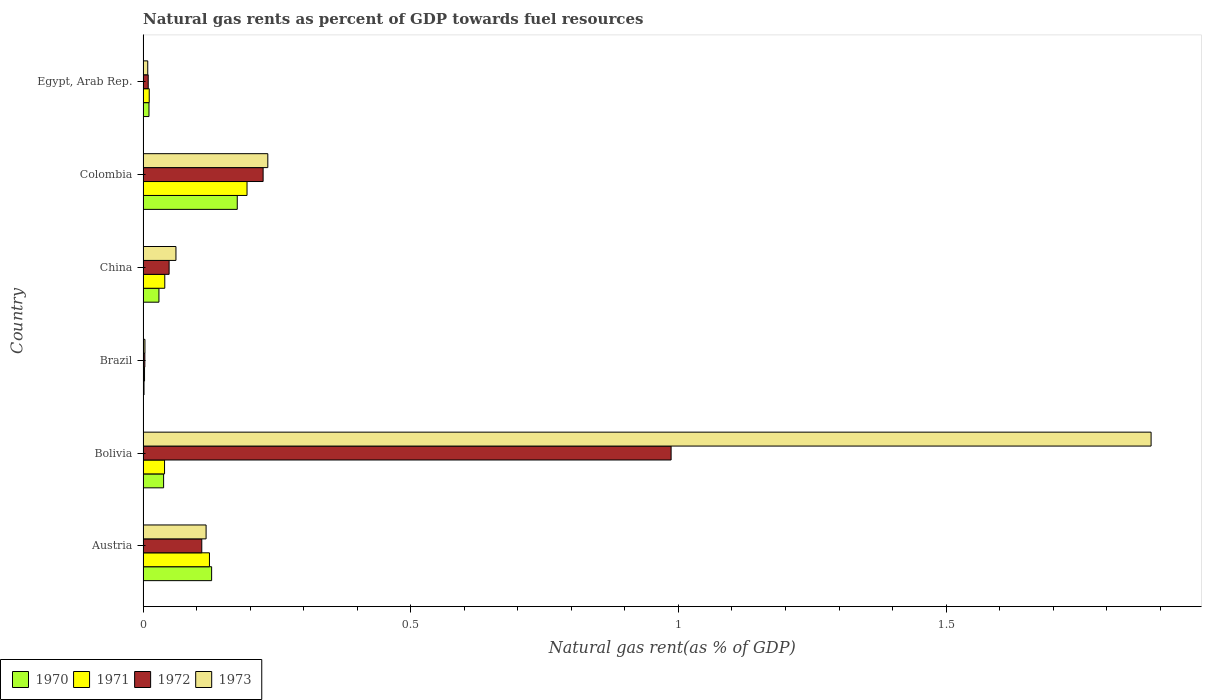How many different coloured bars are there?
Your answer should be compact. 4. How many groups of bars are there?
Offer a very short reply. 6. Are the number of bars per tick equal to the number of legend labels?
Give a very brief answer. Yes. How many bars are there on the 1st tick from the top?
Provide a short and direct response. 4. What is the natural gas rent in 1971 in China?
Make the answer very short. 0.04. Across all countries, what is the maximum natural gas rent in 1973?
Your response must be concise. 1.88. Across all countries, what is the minimum natural gas rent in 1971?
Provide a succinct answer. 0. In which country was the natural gas rent in 1971 maximum?
Your answer should be very brief. Colombia. What is the total natural gas rent in 1970 in the graph?
Offer a very short reply. 0.38. What is the difference between the natural gas rent in 1970 in Bolivia and that in Brazil?
Provide a succinct answer. 0.04. What is the difference between the natural gas rent in 1973 in Egypt, Arab Rep. and the natural gas rent in 1972 in Brazil?
Your answer should be very brief. 0.01. What is the average natural gas rent in 1971 per country?
Make the answer very short. 0.07. What is the difference between the natural gas rent in 1970 and natural gas rent in 1972 in Bolivia?
Provide a short and direct response. -0.95. In how many countries, is the natural gas rent in 1973 greater than 1.3 %?
Keep it short and to the point. 1. What is the ratio of the natural gas rent in 1972 in Brazil to that in China?
Your answer should be very brief. 0.07. What is the difference between the highest and the second highest natural gas rent in 1972?
Offer a very short reply. 0.76. What is the difference between the highest and the lowest natural gas rent in 1971?
Keep it short and to the point. 0.19. In how many countries, is the natural gas rent in 1970 greater than the average natural gas rent in 1970 taken over all countries?
Your response must be concise. 2. Is it the case that in every country, the sum of the natural gas rent in 1973 and natural gas rent in 1970 is greater than the sum of natural gas rent in 1971 and natural gas rent in 1972?
Make the answer very short. No. What does the 4th bar from the top in China represents?
Keep it short and to the point. 1970. What does the 3rd bar from the bottom in Austria represents?
Ensure brevity in your answer.  1972. How many bars are there?
Keep it short and to the point. 24. How many countries are there in the graph?
Provide a succinct answer. 6. Does the graph contain any zero values?
Ensure brevity in your answer.  No. How many legend labels are there?
Provide a succinct answer. 4. How are the legend labels stacked?
Keep it short and to the point. Horizontal. What is the title of the graph?
Offer a very short reply. Natural gas rents as percent of GDP towards fuel resources. What is the label or title of the X-axis?
Provide a short and direct response. Natural gas rent(as % of GDP). What is the Natural gas rent(as % of GDP) of 1970 in Austria?
Your answer should be very brief. 0.13. What is the Natural gas rent(as % of GDP) of 1971 in Austria?
Your answer should be compact. 0.12. What is the Natural gas rent(as % of GDP) of 1972 in Austria?
Your answer should be compact. 0.11. What is the Natural gas rent(as % of GDP) in 1973 in Austria?
Offer a very short reply. 0.12. What is the Natural gas rent(as % of GDP) in 1970 in Bolivia?
Your answer should be compact. 0.04. What is the Natural gas rent(as % of GDP) in 1971 in Bolivia?
Your answer should be compact. 0.04. What is the Natural gas rent(as % of GDP) in 1972 in Bolivia?
Your answer should be very brief. 0.99. What is the Natural gas rent(as % of GDP) in 1973 in Bolivia?
Make the answer very short. 1.88. What is the Natural gas rent(as % of GDP) of 1970 in Brazil?
Keep it short and to the point. 0. What is the Natural gas rent(as % of GDP) in 1971 in Brazil?
Your response must be concise. 0. What is the Natural gas rent(as % of GDP) of 1972 in Brazil?
Give a very brief answer. 0. What is the Natural gas rent(as % of GDP) in 1973 in Brazil?
Offer a terse response. 0. What is the Natural gas rent(as % of GDP) in 1970 in China?
Offer a terse response. 0.03. What is the Natural gas rent(as % of GDP) in 1971 in China?
Offer a very short reply. 0.04. What is the Natural gas rent(as % of GDP) in 1972 in China?
Offer a terse response. 0.05. What is the Natural gas rent(as % of GDP) of 1973 in China?
Your answer should be compact. 0.06. What is the Natural gas rent(as % of GDP) in 1970 in Colombia?
Make the answer very short. 0.18. What is the Natural gas rent(as % of GDP) of 1971 in Colombia?
Offer a terse response. 0.19. What is the Natural gas rent(as % of GDP) in 1972 in Colombia?
Offer a very short reply. 0.22. What is the Natural gas rent(as % of GDP) in 1973 in Colombia?
Provide a succinct answer. 0.23. What is the Natural gas rent(as % of GDP) in 1970 in Egypt, Arab Rep.?
Ensure brevity in your answer.  0.01. What is the Natural gas rent(as % of GDP) of 1971 in Egypt, Arab Rep.?
Keep it short and to the point. 0.01. What is the Natural gas rent(as % of GDP) in 1972 in Egypt, Arab Rep.?
Make the answer very short. 0.01. What is the Natural gas rent(as % of GDP) in 1973 in Egypt, Arab Rep.?
Make the answer very short. 0.01. Across all countries, what is the maximum Natural gas rent(as % of GDP) in 1970?
Your answer should be very brief. 0.18. Across all countries, what is the maximum Natural gas rent(as % of GDP) of 1971?
Your response must be concise. 0.19. Across all countries, what is the maximum Natural gas rent(as % of GDP) in 1972?
Offer a very short reply. 0.99. Across all countries, what is the maximum Natural gas rent(as % of GDP) in 1973?
Give a very brief answer. 1.88. Across all countries, what is the minimum Natural gas rent(as % of GDP) in 1970?
Provide a succinct answer. 0. Across all countries, what is the minimum Natural gas rent(as % of GDP) in 1971?
Provide a succinct answer. 0. Across all countries, what is the minimum Natural gas rent(as % of GDP) in 1972?
Give a very brief answer. 0. Across all countries, what is the minimum Natural gas rent(as % of GDP) in 1973?
Make the answer very short. 0. What is the total Natural gas rent(as % of GDP) of 1970 in the graph?
Provide a short and direct response. 0.38. What is the total Natural gas rent(as % of GDP) in 1971 in the graph?
Your response must be concise. 0.41. What is the total Natural gas rent(as % of GDP) of 1972 in the graph?
Ensure brevity in your answer.  1.38. What is the total Natural gas rent(as % of GDP) of 1973 in the graph?
Offer a terse response. 2.31. What is the difference between the Natural gas rent(as % of GDP) of 1970 in Austria and that in Bolivia?
Provide a succinct answer. 0.09. What is the difference between the Natural gas rent(as % of GDP) of 1971 in Austria and that in Bolivia?
Offer a very short reply. 0.08. What is the difference between the Natural gas rent(as % of GDP) of 1972 in Austria and that in Bolivia?
Your answer should be very brief. -0.88. What is the difference between the Natural gas rent(as % of GDP) of 1973 in Austria and that in Bolivia?
Keep it short and to the point. -1.77. What is the difference between the Natural gas rent(as % of GDP) in 1970 in Austria and that in Brazil?
Offer a very short reply. 0.13. What is the difference between the Natural gas rent(as % of GDP) of 1971 in Austria and that in Brazil?
Provide a short and direct response. 0.12. What is the difference between the Natural gas rent(as % of GDP) of 1972 in Austria and that in Brazil?
Make the answer very short. 0.11. What is the difference between the Natural gas rent(as % of GDP) in 1973 in Austria and that in Brazil?
Give a very brief answer. 0.11. What is the difference between the Natural gas rent(as % of GDP) of 1970 in Austria and that in China?
Make the answer very short. 0.1. What is the difference between the Natural gas rent(as % of GDP) in 1971 in Austria and that in China?
Provide a succinct answer. 0.08. What is the difference between the Natural gas rent(as % of GDP) in 1972 in Austria and that in China?
Keep it short and to the point. 0.06. What is the difference between the Natural gas rent(as % of GDP) of 1973 in Austria and that in China?
Make the answer very short. 0.06. What is the difference between the Natural gas rent(as % of GDP) of 1970 in Austria and that in Colombia?
Your answer should be compact. -0.05. What is the difference between the Natural gas rent(as % of GDP) of 1971 in Austria and that in Colombia?
Provide a succinct answer. -0.07. What is the difference between the Natural gas rent(as % of GDP) of 1972 in Austria and that in Colombia?
Your answer should be very brief. -0.11. What is the difference between the Natural gas rent(as % of GDP) of 1973 in Austria and that in Colombia?
Keep it short and to the point. -0.12. What is the difference between the Natural gas rent(as % of GDP) in 1970 in Austria and that in Egypt, Arab Rep.?
Give a very brief answer. 0.12. What is the difference between the Natural gas rent(as % of GDP) of 1971 in Austria and that in Egypt, Arab Rep.?
Your response must be concise. 0.11. What is the difference between the Natural gas rent(as % of GDP) of 1972 in Austria and that in Egypt, Arab Rep.?
Give a very brief answer. 0.1. What is the difference between the Natural gas rent(as % of GDP) in 1973 in Austria and that in Egypt, Arab Rep.?
Offer a very short reply. 0.11. What is the difference between the Natural gas rent(as % of GDP) in 1970 in Bolivia and that in Brazil?
Your answer should be very brief. 0.04. What is the difference between the Natural gas rent(as % of GDP) of 1971 in Bolivia and that in Brazil?
Ensure brevity in your answer.  0.04. What is the difference between the Natural gas rent(as % of GDP) of 1973 in Bolivia and that in Brazil?
Ensure brevity in your answer.  1.88. What is the difference between the Natural gas rent(as % of GDP) in 1970 in Bolivia and that in China?
Give a very brief answer. 0.01. What is the difference between the Natural gas rent(as % of GDP) of 1971 in Bolivia and that in China?
Provide a succinct answer. -0. What is the difference between the Natural gas rent(as % of GDP) in 1972 in Bolivia and that in China?
Your answer should be very brief. 0.94. What is the difference between the Natural gas rent(as % of GDP) in 1973 in Bolivia and that in China?
Your answer should be very brief. 1.82. What is the difference between the Natural gas rent(as % of GDP) of 1970 in Bolivia and that in Colombia?
Your response must be concise. -0.14. What is the difference between the Natural gas rent(as % of GDP) in 1971 in Bolivia and that in Colombia?
Offer a very short reply. -0.15. What is the difference between the Natural gas rent(as % of GDP) in 1972 in Bolivia and that in Colombia?
Give a very brief answer. 0.76. What is the difference between the Natural gas rent(as % of GDP) in 1973 in Bolivia and that in Colombia?
Give a very brief answer. 1.65. What is the difference between the Natural gas rent(as % of GDP) in 1970 in Bolivia and that in Egypt, Arab Rep.?
Offer a very short reply. 0.03. What is the difference between the Natural gas rent(as % of GDP) of 1971 in Bolivia and that in Egypt, Arab Rep.?
Offer a very short reply. 0.03. What is the difference between the Natural gas rent(as % of GDP) in 1972 in Bolivia and that in Egypt, Arab Rep.?
Ensure brevity in your answer.  0.98. What is the difference between the Natural gas rent(as % of GDP) of 1973 in Bolivia and that in Egypt, Arab Rep.?
Your answer should be very brief. 1.87. What is the difference between the Natural gas rent(as % of GDP) in 1970 in Brazil and that in China?
Give a very brief answer. -0.03. What is the difference between the Natural gas rent(as % of GDP) of 1971 in Brazil and that in China?
Provide a succinct answer. -0.04. What is the difference between the Natural gas rent(as % of GDP) in 1972 in Brazil and that in China?
Keep it short and to the point. -0.05. What is the difference between the Natural gas rent(as % of GDP) of 1973 in Brazil and that in China?
Provide a short and direct response. -0.06. What is the difference between the Natural gas rent(as % of GDP) of 1970 in Brazil and that in Colombia?
Your answer should be very brief. -0.17. What is the difference between the Natural gas rent(as % of GDP) of 1971 in Brazil and that in Colombia?
Provide a short and direct response. -0.19. What is the difference between the Natural gas rent(as % of GDP) in 1972 in Brazil and that in Colombia?
Provide a succinct answer. -0.22. What is the difference between the Natural gas rent(as % of GDP) of 1973 in Brazil and that in Colombia?
Your response must be concise. -0.23. What is the difference between the Natural gas rent(as % of GDP) of 1970 in Brazil and that in Egypt, Arab Rep.?
Your answer should be compact. -0.01. What is the difference between the Natural gas rent(as % of GDP) in 1971 in Brazil and that in Egypt, Arab Rep.?
Your response must be concise. -0.01. What is the difference between the Natural gas rent(as % of GDP) of 1972 in Brazil and that in Egypt, Arab Rep.?
Ensure brevity in your answer.  -0.01. What is the difference between the Natural gas rent(as % of GDP) of 1973 in Brazil and that in Egypt, Arab Rep.?
Provide a short and direct response. -0.01. What is the difference between the Natural gas rent(as % of GDP) in 1970 in China and that in Colombia?
Your answer should be very brief. -0.15. What is the difference between the Natural gas rent(as % of GDP) of 1971 in China and that in Colombia?
Offer a very short reply. -0.15. What is the difference between the Natural gas rent(as % of GDP) in 1972 in China and that in Colombia?
Ensure brevity in your answer.  -0.18. What is the difference between the Natural gas rent(as % of GDP) in 1973 in China and that in Colombia?
Ensure brevity in your answer.  -0.17. What is the difference between the Natural gas rent(as % of GDP) in 1970 in China and that in Egypt, Arab Rep.?
Your answer should be compact. 0.02. What is the difference between the Natural gas rent(as % of GDP) in 1971 in China and that in Egypt, Arab Rep.?
Ensure brevity in your answer.  0.03. What is the difference between the Natural gas rent(as % of GDP) in 1972 in China and that in Egypt, Arab Rep.?
Keep it short and to the point. 0.04. What is the difference between the Natural gas rent(as % of GDP) in 1973 in China and that in Egypt, Arab Rep.?
Offer a terse response. 0.05. What is the difference between the Natural gas rent(as % of GDP) in 1970 in Colombia and that in Egypt, Arab Rep.?
Your answer should be compact. 0.16. What is the difference between the Natural gas rent(as % of GDP) in 1971 in Colombia and that in Egypt, Arab Rep.?
Offer a very short reply. 0.18. What is the difference between the Natural gas rent(as % of GDP) in 1972 in Colombia and that in Egypt, Arab Rep.?
Your response must be concise. 0.21. What is the difference between the Natural gas rent(as % of GDP) of 1973 in Colombia and that in Egypt, Arab Rep.?
Your answer should be compact. 0.22. What is the difference between the Natural gas rent(as % of GDP) of 1970 in Austria and the Natural gas rent(as % of GDP) of 1971 in Bolivia?
Offer a very short reply. 0.09. What is the difference between the Natural gas rent(as % of GDP) of 1970 in Austria and the Natural gas rent(as % of GDP) of 1972 in Bolivia?
Make the answer very short. -0.86. What is the difference between the Natural gas rent(as % of GDP) of 1970 in Austria and the Natural gas rent(as % of GDP) of 1973 in Bolivia?
Your response must be concise. -1.75. What is the difference between the Natural gas rent(as % of GDP) of 1971 in Austria and the Natural gas rent(as % of GDP) of 1972 in Bolivia?
Your answer should be compact. -0.86. What is the difference between the Natural gas rent(as % of GDP) of 1971 in Austria and the Natural gas rent(as % of GDP) of 1973 in Bolivia?
Offer a very short reply. -1.76. What is the difference between the Natural gas rent(as % of GDP) of 1972 in Austria and the Natural gas rent(as % of GDP) of 1973 in Bolivia?
Make the answer very short. -1.77. What is the difference between the Natural gas rent(as % of GDP) of 1970 in Austria and the Natural gas rent(as % of GDP) of 1971 in Brazil?
Your answer should be very brief. 0.13. What is the difference between the Natural gas rent(as % of GDP) of 1970 in Austria and the Natural gas rent(as % of GDP) of 1972 in Brazil?
Provide a short and direct response. 0.12. What is the difference between the Natural gas rent(as % of GDP) of 1970 in Austria and the Natural gas rent(as % of GDP) of 1973 in Brazil?
Offer a very short reply. 0.12. What is the difference between the Natural gas rent(as % of GDP) in 1971 in Austria and the Natural gas rent(as % of GDP) in 1972 in Brazil?
Your response must be concise. 0.12. What is the difference between the Natural gas rent(as % of GDP) of 1971 in Austria and the Natural gas rent(as % of GDP) of 1973 in Brazil?
Your answer should be very brief. 0.12. What is the difference between the Natural gas rent(as % of GDP) of 1972 in Austria and the Natural gas rent(as % of GDP) of 1973 in Brazil?
Give a very brief answer. 0.11. What is the difference between the Natural gas rent(as % of GDP) in 1970 in Austria and the Natural gas rent(as % of GDP) in 1971 in China?
Your answer should be very brief. 0.09. What is the difference between the Natural gas rent(as % of GDP) in 1970 in Austria and the Natural gas rent(as % of GDP) in 1972 in China?
Offer a very short reply. 0.08. What is the difference between the Natural gas rent(as % of GDP) in 1970 in Austria and the Natural gas rent(as % of GDP) in 1973 in China?
Offer a terse response. 0.07. What is the difference between the Natural gas rent(as % of GDP) in 1971 in Austria and the Natural gas rent(as % of GDP) in 1972 in China?
Your answer should be very brief. 0.08. What is the difference between the Natural gas rent(as % of GDP) of 1971 in Austria and the Natural gas rent(as % of GDP) of 1973 in China?
Offer a very short reply. 0.06. What is the difference between the Natural gas rent(as % of GDP) in 1972 in Austria and the Natural gas rent(as % of GDP) in 1973 in China?
Offer a very short reply. 0.05. What is the difference between the Natural gas rent(as % of GDP) of 1970 in Austria and the Natural gas rent(as % of GDP) of 1971 in Colombia?
Give a very brief answer. -0.07. What is the difference between the Natural gas rent(as % of GDP) of 1970 in Austria and the Natural gas rent(as % of GDP) of 1972 in Colombia?
Your answer should be compact. -0.1. What is the difference between the Natural gas rent(as % of GDP) of 1970 in Austria and the Natural gas rent(as % of GDP) of 1973 in Colombia?
Keep it short and to the point. -0.1. What is the difference between the Natural gas rent(as % of GDP) of 1971 in Austria and the Natural gas rent(as % of GDP) of 1972 in Colombia?
Provide a short and direct response. -0.1. What is the difference between the Natural gas rent(as % of GDP) of 1971 in Austria and the Natural gas rent(as % of GDP) of 1973 in Colombia?
Ensure brevity in your answer.  -0.11. What is the difference between the Natural gas rent(as % of GDP) in 1972 in Austria and the Natural gas rent(as % of GDP) in 1973 in Colombia?
Give a very brief answer. -0.12. What is the difference between the Natural gas rent(as % of GDP) in 1970 in Austria and the Natural gas rent(as % of GDP) in 1971 in Egypt, Arab Rep.?
Provide a succinct answer. 0.12. What is the difference between the Natural gas rent(as % of GDP) of 1970 in Austria and the Natural gas rent(as % of GDP) of 1972 in Egypt, Arab Rep.?
Make the answer very short. 0.12. What is the difference between the Natural gas rent(as % of GDP) in 1970 in Austria and the Natural gas rent(as % of GDP) in 1973 in Egypt, Arab Rep.?
Your answer should be very brief. 0.12. What is the difference between the Natural gas rent(as % of GDP) of 1971 in Austria and the Natural gas rent(as % of GDP) of 1972 in Egypt, Arab Rep.?
Your answer should be compact. 0.11. What is the difference between the Natural gas rent(as % of GDP) of 1971 in Austria and the Natural gas rent(as % of GDP) of 1973 in Egypt, Arab Rep.?
Your answer should be compact. 0.12. What is the difference between the Natural gas rent(as % of GDP) in 1972 in Austria and the Natural gas rent(as % of GDP) in 1973 in Egypt, Arab Rep.?
Offer a terse response. 0.1. What is the difference between the Natural gas rent(as % of GDP) of 1970 in Bolivia and the Natural gas rent(as % of GDP) of 1971 in Brazil?
Offer a very short reply. 0.04. What is the difference between the Natural gas rent(as % of GDP) in 1970 in Bolivia and the Natural gas rent(as % of GDP) in 1972 in Brazil?
Your answer should be compact. 0.04. What is the difference between the Natural gas rent(as % of GDP) in 1970 in Bolivia and the Natural gas rent(as % of GDP) in 1973 in Brazil?
Keep it short and to the point. 0.03. What is the difference between the Natural gas rent(as % of GDP) of 1971 in Bolivia and the Natural gas rent(as % of GDP) of 1972 in Brazil?
Offer a terse response. 0.04. What is the difference between the Natural gas rent(as % of GDP) of 1971 in Bolivia and the Natural gas rent(as % of GDP) of 1973 in Brazil?
Provide a succinct answer. 0.04. What is the difference between the Natural gas rent(as % of GDP) of 1972 in Bolivia and the Natural gas rent(as % of GDP) of 1973 in Brazil?
Make the answer very short. 0.98. What is the difference between the Natural gas rent(as % of GDP) of 1970 in Bolivia and the Natural gas rent(as % of GDP) of 1971 in China?
Provide a succinct answer. -0. What is the difference between the Natural gas rent(as % of GDP) of 1970 in Bolivia and the Natural gas rent(as % of GDP) of 1972 in China?
Your answer should be compact. -0.01. What is the difference between the Natural gas rent(as % of GDP) of 1970 in Bolivia and the Natural gas rent(as % of GDP) of 1973 in China?
Keep it short and to the point. -0.02. What is the difference between the Natural gas rent(as % of GDP) of 1971 in Bolivia and the Natural gas rent(as % of GDP) of 1972 in China?
Ensure brevity in your answer.  -0.01. What is the difference between the Natural gas rent(as % of GDP) in 1971 in Bolivia and the Natural gas rent(as % of GDP) in 1973 in China?
Ensure brevity in your answer.  -0.02. What is the difference between the Natural gas rent(as % of GDP) in 1972 in Bolivia and the Natural gas rent(as % of GDP) in 1973 in China?
Ensure brevity in your answer.  0.92. What is the difference between the Natural gas rent(as % of GDP) of 1970 in Bolivia and the Natural gas rent(as % of GDP) of 1971 in Colombia?
Your answer should be very brief. -0.16. What is the difference between the Natural gas rent(as % of GDP) of 1970 in Bolivia and the Natural gas rent(as % of GDP) of 1972 in Colombia?
Give a very brief answer. -0.19. What is the difference between the Natural gas rent(as % of GDP) of 1970 in Bolivia and the Natural gas rent(as % of GDP) of 1973 in Colombia?
Keep it short and to the point. -0.19. What is the difference between the Natural gas rent(as % of GDP) in 1971 in Bolivia and the Natural gas rent(as % of GDP) in 1972 in Colombia?
Give a very brief answer. -0.18. What is the difference between the Natural gas rent(as % of GDP) in 1971 in Bolivia and the Natural gas rent(as % of GDP) in 1973 in Colombia?
Your answer should be compact. -0.19. What is the difference between the Natural gas rent(as % of GDP) in 1972 in Bolivia and the Natural gas rent(as % of GDP) in 1973 in Colombia?
Keep it short and to the point. 0.75. What is the difference between the Natural gas rent(as % of GDP) of 1970 in Bolivia and the Natural gas rent(as % of GDP) of 1971 in Egypt, Arab Rep.?
Your answer should be compact. 0.03. What is the difference between the Natural gas rent(as % of GDP) in 1970 in Bolivia and the Natural gas rent(as % of GDP) in 1972 in Egypt, Arab Rep.?
Give a very brief answer. 0.03. What is the difference between the Natural gas rent(as % of GDP) of 1970 in Bolivia and the Natural gas rent(as % of GDP) of 1973 in Egypt, Arab Rep.?
Provide a short and direct response. 0.03. What is the difference between the Natural gas rent(as % of GDP) in 1971 in Bolivia and the Natural gas rent(as % of GDP) in 1972 in Egypt, Arab Rep.?
Keep it short and to the point. 0.03. What is the difference between the Natural gas rent(as % of GDP) in 1971 in Bolivia and the Natural gas rent(as % of GDP) in 1973 in Egypt, Arab Rep.?
Make the answer very short. 0.03. What is the difference between the Natural gas rent(as % of GDP) of 1972 in Bolivia and the Natural gas rent(as % of GDP) of 1973 in Egypt, Arab Rep.?
Offer a terse response. 0.98. What is the difference between the Natural gas rent(as % of GDP) of 1970 in Brazil and the Natural gas rent(as % of GDP) of 1971 in China?
Offer a very short reply. -0.04. What is the difference between the Natural gas rent(as % of GDP) of 1970 in Brazil and the Natural gas rent(as % of GDP) of 1972 in China?
Your answer should be very brief. -0.05. What is the difference between the Natural gas rent(as % of GDP) in 1970 in Brazil and the Natural gas rent(as % of GDP) in 1973 in China?
Make the answer very short. -0.06. What is the difference between the Natural gas rent(as % of GDP) of 1971 in Brazil and the Natural gas rent(as % of GDP) of 1972 in China?
Provide a succinct answer. -0.05. What is the difference between the Natural gas rent(as % of GDP) in 1971 in Brazil and the Natural gas rent(as % of GDP) in 1973 in China?
Your answer should be very brief. -0.06. What is the difference between the Natural gas rent(as % of GDP) of 1972 in Brazil and the Natural gas rent(as % of GDP) of 1973 in China?
Your answer should be compact. -0.06. What is the difference between the Natural gas rent(as % of GDP) of 1970 in Brazil and the Natural gas rent(as % of GDP) of 1971 in Colombia?
Provide a short and direct response. -0.19. What is the difference between the Natural gas rent(as % of GDP) of 1970 in Brazil and the Natural gas rent(as % of GDP) of 1972 in Colombia?
Provide a succinct answer. -0.22. What is the difference between the Natural gas rent(as % of GDP) of 1970 in Brazil and the Natural gas rent(as % of GDP) of 1973 in Colombia?
Your answer should be compact. -0.23. What is the difference between the Natural gas rent(as % of GDP) in 1971 in Brazil and the Natural gas rent(as % of GDP) in 1972 in Colombia?
Provide a short and direct response. -0.22. What is the difference between the Natural gas rent(as % of GDP) of 1971 in Brazil and the Natural gas rent(as % of GDP) of 1973 in Colombia?
Offer a terse response. -0.23. What is the difference between the Natural gas rent(as % of GDP) of 1972 in Brazil and the Natural gas rent(as % of GDP) of 1973 in Colombia?
Ensure brevity in your answer.  -0.23. What is the difference between the Natural gas rent(as % of GDP) in 1970 in Brazil and the Natural gas rent(as % of GDP) in 1971 in Egypt, Arab Rep.?
Offer a very short reply. -0.01. What is the difference between the Natural gas rent(as % of GDP) of 1970 in Brazil and the Natural gas rent(as % of GDP) of 1972 in Egypt, Arab Rep.?
Your response must be concise. -0.01. What is the difference between the Natural gas rent(as % of GDP) of 1970 in Brazil and the Natural gas rent(as % of GDP) of 1973 in Egypt, Arab Rep.?
Keep it short and to the point. -0.01. What is the difference between the Natural gas rent(as % of GDP) of 1971 in Brazil and the Natural gas rent(as % of GDP) of 1972 in Egypt, Arab Rep.?
Give a very brief answer. -0.01. What is the difference between the Natural gas rent(as % of GDP) of 1971 in Brazil and the Natural gas rent(as % of GDP) of 1973 in Egypt, Arab Rep.?
Your response must be concise. -0.01. What is the difference between the Natural gas rent(as % of GDP) in 1972 in Brazil and the Natural gas rent(as % of GDP) in 1973 in Egypt, Arab Rep.?
Ensure brevity in your answer.  -0.01. What is the difference between the Natural gas rent(as % of GDP) of 1970 in China and the Natural gas rent(as % of GDP) of 1971 in Colombia?
Offer a very short reply. -0.16. What is the difference between the Natural gas rent(as % of GDP) in 1970 in China and the Natural gas rent(as % of GDP) in 1972 in Colombia?
Your answer should be compact. -0.19. What is the difference between the Natural gas rent(as % of GDP) in 1970 in China and the Natural gas rent(as % of GDP) in 1973 in Colombia?
Make the answer very short. -0.2. What is the difference between the Natural gas rent(as % of GDP) in 1971 in China and the Natural gas rent(as % of GDP) in 1972 in Colombia?
Keep it short and to the point. -0.18. What is the difference between the Natural gas rent(as % of GDP) of 1971 in China and the Natural gas rent(as % of GDP) of 1973 in Colombia?
Offer a very short reply. -0.19. What is the difference between the Natural gas rent(as % of GDP) in 1972 in China and the Natural gas rent(as % of GDP) in 1973 in Colombia?
Provide a succinct answer. -0.18. What is the difference between the Natural gas rent(as % of GDP) in 1970 in China and the Natural gas rent(as % of GDP) in 1971 in Egypt, Arab Rep.?
Provide a short and direct response. 0.02. What is the difference between the Natural gas rent(as % of GDP) in 1970 in China and the Natural gas rent(as % of GDP) in 1972 in Egypt, Arab Rep.?
Make the answer very short. 0.02. What is the difference between the Natural gas rent(as % of GDP) of 1970 in China and the Natural gas rent(as % of GDP) of 1973 in Egypt, Arab Rep.?
Offer a terse response. 0.02. What is the difference between the Natural gas rent(as % of GDP) of 1971 in China and the Natural gas rent(as % of GDP) of 1972 in Egypt, Arab Rep.?
Give a very brief answer. 0.03. What is the difference between the Natural gas rent(as % of GDP) in 1971 in China and the Natural gas rent(as % of GDP) in 1973 in Egypt, Arab Rep.?
Give a very brief answer. 0.03. What is the difference between the Natural gas rent(as % of GDP) of 1972 in China and the Natural gas rent(as % of GDP) of 1973 in Egypt, Arab Rep.?
Your answer should be very brief. 0.04. What is the difference between the Natural gas rent(as % of GDP) in 1970 in Colombia and the Natural gas rent(as % of GDP) in 1971 in Egypt, Arab Rep.?
Your answer should be compact. 0.16. What is the difference between the Natural gas rent(as % of GDP) of 1970 in Colombia and the Natural gas rent(as % of GDP) of 1972 in Egypt, Arab Rep.?
Make the answer very short. 0.17. What is the difference between the Natural gas rent(as % of GDP) in 1970 in Colombia and the Natural gas rent(as % of GDP) in 1973 in Egypt, Arab Rep.?
Keep it short and to the point. 0.17. What is the difference between the Natural gas rent(as % of GDP) in 1971 in Colombia and the Natural gas rent(as % of GDP) in 1972 in Egypt, Arab Rep.?
Ensure brevity in your answer.  0.18. What is the difference between the Natural gas rent(as % of GDP) of 1971 in Colombia and the Natural gas rent(as % of GDP) of 1973 in Egypt, Arab Rep.?
Keep it short and to the point. 0.19. What is the difference between the Natural gas rent(as % of GDP) of 1972 in Colombia and the Natural gas rent(as % of GDP) of 1973 in Egypt, Arab Rep.?
Your response must be concise. 0.22. What is the average Natural gas rent(as % of GDP) of 1970 per country?
Offer a very short reply. 0.06. What is the average Natural gas rent(as % of GDP) of 1971 per country?
Offer a very short reply. 0.07. What is the average Natural gas rent(as % of GDP) of 1972 per country?
Your answer should be very brief. 0.23. What is the average Natural gas rent(as % of GDP) of 1973 per country?
Make the answer very short. 0.38. What is the difference between the Natural gas rent(as % of GDP) of 1970 and Natural gas rent(as % of GDP) of 1971 in Austria?
Make the answer very short. 0. What is the difference between the Natural gas rent(as % of GDP) in 1970 and Natural gas rent(as % of GDP) in 1972 in Austria?
Provide a succinct answer. 0.02. What is the difference between the Natural gas rent(as % of GDP) in 1970 and Natural gas rent(as % of GDP) in 1973 in Austria?
Give a very brief answer. 0.01. What is the difference between the Natural gas rent(as % of GDP) of 1971 and Natural gas rent(as % of GDP) of 1972 in Austria?
Give a very brief answer. 0.01. What is the difference between the Natural gas rent(as % of GDP) in 1971 and Natural gas rent(as % of GDP) in 1973 in Austria?
Keep it short and to the point. 0.01. What is the difference between the Natural gas rent(as % of GDP) in 1972 and Natural gas rent(as % of GDP) in 1973 in Austria?
Keep it short and to the point. -0.01. What is the difference between the Natural gas rent(as % of GDP) in 1970 and Natural gas rent(as % of GDP) in 1971 in Bolivia?
Offer a very short reply. -0. What is the difference between the Natural gas rent(as % of GDP) in 1970 and Natural gas rent(as % of GDP) in 1972 in Bolivia?
Make the answer very short. -0.95. What is the difference between the Natural gas rent(as % of GDP) of 1970 and Natural gas rent(as % of GDP) of 1973 in Bolivia?
Your response must be concise. -1.84. What is the difference between the Natural gas rent(as % of GDP) of 1971 and Natural gas rent(as % of GDP) of 1972 in Bolivia?
Offer a terse response. -0.95. What is the difference between the Natural gas rent(as % of GDP) of 1971 and Natural gas rent(as % of GDP) of 1973 in Bolivia?
Provide a succinct answer. -1.84. What is the difference between the Natural gas rent(as % of GDP) in 1972 and Natural gas rent(as % of GDP) in 1973 in Bolivia?
Keep it short and to the point. -0.9. What is the difference between the Natural gas rent(as % of GDP) in 1970 and Natural gas rent(as % of GDP) in 1971 in Brazil?
Give a very brief answer. -0. What is the difference between the Natural gas rent(as % of GDP) in 1970 and Natural gas rent(as % of GDP) in 1972 in Brazil?
Offer a terse response. -0. What is the difference between the Natural gas rent(as % of GDP) in 1970 and Natural gas rent(as % of GDP) in 1973 in Brazil?
Give a very brief answer. -0. What is the difference between the Natural gas rent(as % of GDP) in 1971 and Natural gas rent(as % of GDP) in 1972 in Brazil?
Offer a very short reply. -0. What is the difference between the Natural gas rent(as % of GDP) in 1971 and Natural gas rent(as % of GDP) in 1973 in Brazil?
Provide a succinct answer. -0. What is the difference between the Natural gas rent(as % of GDP) of 1972 and Natural gas rent(as % of GDP) of 1973 in Brazil?
Offer a very short reply. -0. What is the difference between the Natural gas rent(as % of GDP) of 1970 and Natural gas rent(as % of GDP) of 1971 in China?
Your response must be concise. -0.01. What is the difference between the Natural gas rent(as % of GDP) in 1970 and Natural gas rent(as % of GDP) in 1972 in China?
Keep it short and to the point. -0.02. What is the difference between the Natural gas rent(as % of GDP) of 1970 and Natural gas rent(as % of GDP) of 1973 in China?
Ensure brevity in your answer.  -0.03. What is the difference between the Natural gas rent(as % of GDP) in 1971 and Natural gas rent(as % of GDP) in 1972 in China?
Your response must be concise. -0.01. What is the difference between the Natural gas rent(as % of GDP) in 1971 and Natural gas rent(as % of GDP) in 1973 in China?
Your response must be concise. -0.02. What is the difference between the Natural gas rent(as % of GDP) in 1972 and Natural gas rent(as % of GDP) in 1973 in China?
Provide a succinct answer. -0.01. What is the difference between the Natural gas rent(as % of GDP) of 1970 and Natural gas rent(as % of GDP) of 1971 in Colombia?
Give a very brief answer. -0.02. What is the difference between the Natural gas rent(as % of GDP) in 1970 and Natural gas rent(as % of GDP) in 1972 in Colombia?
Provide a short and direct response. -0.05. What is the difference between the Natural gas rent(as % of GDP) of 1970 and Natural gas rent(as % of GDP) of 1973 in Colombia?
Provide a short and direct response. -0.06. What is the difference between the Natural gas rent(as % of GDP) in 1971 and Natural gas rent(as % of GDP) in 1972 in Colombia?
Provide a short and direct response. -0.03. What is the difference between the Natural gas rent(as % of GDP) of 1971 and Natural gas rent(as % of GDP) of 1973 in Colombia?
Make the answer very short. -0.04. What is the difference between the Natural gas rent(as % of GDP) in 1972 and Natural gas rent(as % of GDP) in 1973 in Colombia?
Offer a terse response. -0.01. What is the difference between the Natural gas rent(as % of GDP) of 1970 and Natural gas rent(as % of GDP) of 1971 in Egypt, Arab Rep.?
Your answer should be very brief. -0. What is the difference between the Natural gas rent(as % of GDP) in 1970 and Natural gas rent(as % of GDP) in 1972 in Egypt, Arab Rep.?
Offer a terse response. 0. What is the difference between the Natural gas rent(as % of GDP) in 1970 and Natural gas rent(as % of GDP) in 1973 in Egypt, Arab Rep.?
Ensure brevity in your answer.  0. What is the difference between the Natural gas rent(as % of GDP) of 1971 and Natural gas rent(as % of GDP) of 1972 in Egypt, Arab Rep.?
Offer a very short reply. 0. What is the difference between the Natural gas rent(as % of GDP) in 1971 and Natural gas rent(as % of GDP) in 1973 in Egypt, Arab Rep.?
Provide a short and direct response. 0. What is the difference between the Natural gas rent(as % of GDP) of 1972 and Natural gas rent(as % of GDP) of 1973 in Egypt, Arab Rep.?
Your answer should be very brief. 0. What is the ratio of the Natural gas rent(as % of GDP) of 1970 in Austria to that in Bolivia?
Your response must be concise. 3.34. What is the ratio of the Natural gas rent(as % of GDP) of 1971 in Austria to that in Bolivia?
Make the answer very short. 3.09. What is the ratio of the Natural gas rent(as % of GDP) in 1972 in Austria to that in Bolivia?
Provide a succinct answer. 0.11. What is the ratio of the Natural gas rent(as % of GDP) in 1973 in Austria to that in Bolivia?
Give a very brief answer. 0.06. What is the ratio of the Natural gas rent(as % of GDP) in 1970 in Austria to that in Brazil?
Make the answer very short. 72. What is the ratio of the Natural gas rent(as % of GDP) in 1971 in Austria to that in Brazil?
Provide a short and direct response. 45.2. What is the ratio of the Natural gas rent(as % of GDP) in 1972 in Austria to that in Brazil?
Ensure brevity in your answer.  33.07. What is the ratio of the Natural gas rent(as % of GDP) in 1973 in Austria to that in Brazil?
Give a very brief answer. 33.74. What is the ratio of the Natural gas rent(as % of GDP) in 1970 in Austria to that in China?
Offer a terse response. 4.32. What is the ratio of the Natural gas rent(as % of GDP) in 1971 in Austria to that in China?
Keep it short and to the point. 3.06. What is the ratio of the Natural gas rent(as % of GDP) in 1972 in Austria to that in China?
Make the answer very short. 2.25. What is the ratio of the Natural gas rent(as % of GDP) in 1973 in Austria to that in China?
Provide a short and direct response. 1.92. What is the ratio of the Natural gas rent(as % of GDP) in 1970 in Austria to that in Colombia?
Your answer should be very brief. 0.73. What is the ratio of the Natural gas rent(as % of GDP) of 1971 in Austria to that in Colombia?
Provide a succinct answer. 0.64. What is the ratio of the Natural gas rent(as % of GDP) in 1972 in Austria to that in Colombia?
Make the answer very short. 0.49. What is the ratio of the Natural gas rent(as % of GDP) of 1973 in Austria to that in Colombia?
Provide a succinct answer. 0.51. What is the ratio of the Natural gas rent(as % of GDP) of 1970 in Austria to that in Egypt, Arab Rep.?
Keep it short and to the point. 11.57. What is the ratio of the Natural gas rent(as % of GDP) of 1971 in Austria to that in Egypt, Arab Rep.?
Keep it short and to the point. 10.75. What is the ratio of the Natural gas rent(as % of GDP) in 1972 in Austria to that in Egypt, Arab Rep.?
Provide a succinct answer. 11.37. What is the ratio of the Natural gas rent(as % of GDP) in 1973 in Austria to that in Egypt, Arab Rep.?
Ensure brevity in your answer.  13.44. What is the ratio of the Natural gas rent(as % of GDP) of 1970 in Bolivia to that in Brazil?
Offer a very short reply. 21.58. What is the ratio of the Natural gas rent(as % of GDP) in 1971 in Bolivia to that in Brazil?
Provide a short and direct response. 14.62. What is the ratio of the Natural gas rent(as % of GDP) of 1972 in Bolivia to that in Brazil?
Provide a short and direct response. 297.41. What is the ratio of the Natural gas rent(as % of GDP) in 1973 in Bolivia to that in Brazil?
Make the answer very short. 539.46. What is the ratio of the Natural gas rent(as % of GDP) of 1970 in Bolivia to that in China?
Give a very brief answer. 1.3. What is the ratio of the Natural gas rent(as % of GDP) of 1972 in Bolivia to that in China?
Your response must be concise. 20.28. What is the ratio of the Natural gas rent(as % of GDP) of 1973 in Bolivia to that in China?
Your answer should be compact. 30.65. What is the ratio of the Natural gas rent(as % of GDP) of 1970 in Bolivia to that in Colombia?
Make the answer very short. 0.22. What is the ratio of the Natural gas rent(as % of GDP) in 1971 in Bolivia to that in Colombia?
Give a very brief answer. 0.21. What is the ratio of the Natural gas rent(as % of GDP) in 1972 in Bolivia to that in Colombia?
Make the answer very short. 4.4. What is the ratio of the Natural gas rent(as % of GDP) in 1973 in Bolivia to that in Colombia?
Your response must be concise. 8.08. What is the ratio of the Natural gas rent(as % of GDP) of 1970 in Bolivia to that in Egypt, Arab Rep.?
Offer a terse response. 3.47. What is the ratio of the Natural gas rent(as % of GDP) of 1971 in Bolivia to that in Egypt, Arab Rep.?
Offer a terse response. 3.48. What is the ratio of the Natural gas rent(as % of GDP) in 1972 in Bolivia to that in Egypt, Arab Rep.?
Offer a terse response. 102.27. What is the ratio of the Natural gas rent(as % of GDP) in 1973 in Bolivia to that in Egypt, Arab Rep.?
Provide a short and direct response. 214.93. What is the ratio of the Natural gas rent(as % of GDP) in 1970 in Brazil to that in China?
Provide a short and direct response. 0.06. What is the ratio of the Natural gas rent(as % of GDP) of 1971 in Brazil to that in China?
Offer a very short reply. 0.07. What is the ratio of the Natural gas rent(as % of GDP) of 1972 in Brazil to that in China?
Give a very brief answer. 0.07. What is the ratio of the Natural gas rent(as % of GDP) of 1973 in Brazil to that in China?
Ensure brevity in your answer.  0.06. What is the ratio of the Natural gas rent(as % of GDP) in 1970 in Brazil to that in Colombia?
Your answer should be compact. 0.01. What is the ratio of the Natural gas rent(as % of GDP) of 1971 in Brazil to that in Colombia?
Provide a short and direct response. 0.01. What is the ratio of the Natural gas rent(as % of GDP) of 1972 in Brazil to that in Colombia?
Ensure brevity in your answer.  0.01. What is the ratio of the Natural gas rent(as % of GDP) of 1973 in Brazil to that in Colombia?
Keep it short and to the point. 0.01. What is the ratio of the Natural gas rent(as % of GDP) of 1970 in Brazil to that in Egypt, Arab Rep.?
Give a very brief answer. 0.16. What is the ratio of the Natural gas rent(as % of GDP) of 1971 in Brazil to that in Egypt, Arab Rep.?
Keep it short and to the point. 0.24. What is the ratio of the Natural gas rent(as % of GDP) of 1972 in Brazil to that in Egypt, Arab Rep.?
Your answer should be very brief. 0.34. What is the ratio of the Natural gas rent(as % of GDP) of 1973 in Brazil to that in Egypt, Arab Rep.?
Your response must be concise. 0.4. What is the ratio of the Natural gas rent(as % of GDP) in 1970 in China to that in Colombia?
Give a very brief answer. 0.17. What is the ratio of the Natural gas rent(as % of GDP) in 1971 in China to that in Colombia?
Give a very brief answer. 0.21. What is the ratio of the Natural gas rent(as % of GDP) of 1972 in China to that in Colombia?
Make the answer very short. 0.22. What is the ratio of the Natural gas rent(as % of GDP) in 1973 in China to that in Colombia?
Provide a short and direct response. 0.26. What is the ratio of the Natural gas rent(as % of GDP) in 1970 in China to that in Egypt, Arab Rep.?
Your response must be concise. 2.68. What is the ratio of the Natural gas rent(as % of GDP) of 1971 in China to that in Egypt, Arab Rep.?
Ensure brevity in your answer.  3.52. What is the ratio of the Natural gas rent(as % of GDP) of 1972 in China to that in Egypt, Arab Rep.?
Your answer should be very brief. 5.04. What is the ratio of the Natural gas rent(as % of GDP) in 1973 in China to that in Egypt, Arab Rep.?
Keep it short and to the point. 7.01. What is the ratio of the Natural gas rent(as % of GDP) of 1970 in Colombia to that in Egypt, Arab Rep.?
Provide a short and direct response. 15.9. What is the ratio of the Natural gas rent(as % of GDP) of 1971 in Colombia to that in Egypt, Arab Rep.?
Your answer should be compact. 16.84. What is the ratio of the Natural gas rent(as % of GDP) of 1972 in Colombia to that in Egypt, Arab Rep.?
Provide a succinct answer. 23.25. What is the ratio of the Natural gas rent(as % of GDP) of 1973 in Colombia to that in Egypt, Arab Rep.?
Ensure brevity in your answer.  26.6. What is the difference between the highest and the second highest Natural gas rent(as % of GDP) in 1970?
Ensure brevity in your answer.  0.05. What is the difference between the highest and the second highest Natural gas rent(as % of GDP) of 1971?
Offer a very short reply. 0.07. What is the difference between the highest and the second highest Natural gas rent(as % of GDP) of 1972?
Offer a very short reply. 0.76. What is the difference between the highest and the second highest Natural gas rent(as % of GDP) of 1973?
Your answer should be very brief. 1.65. What is the difference between the highest and the lowest Natural gas rent(as % of GDP) in 1970?
Offer a very short reply. 0.17. What is the difference between the highest and the lowest Natural gas rent(as % of GDP) of 1971?
Ensure brevity in your answer.  0.19. What is the difference between the highest and the lowest Natural gas rent(as % of GDP) in 1973?
Your answer should be very brief. 1.88. 